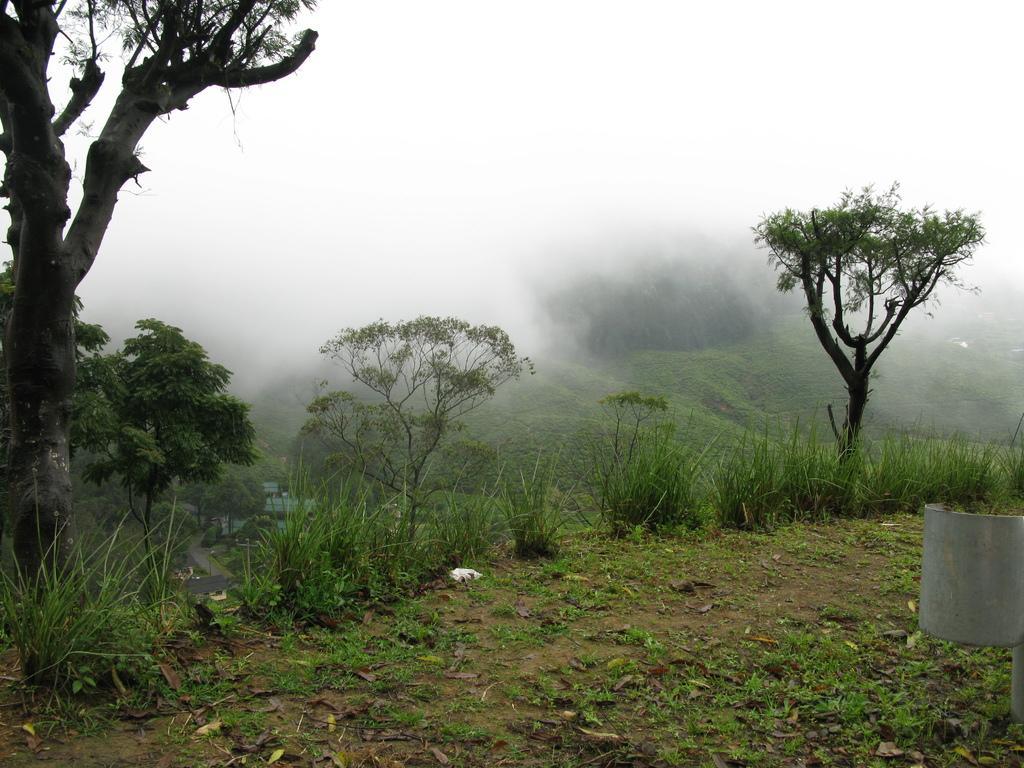Describe this image in one or two sentences. In this image there are small plants and grass on the ground. In the background there are trees. At the top there is fog. On the left side there is a cement pillar. On the ground there are dry leaves. 